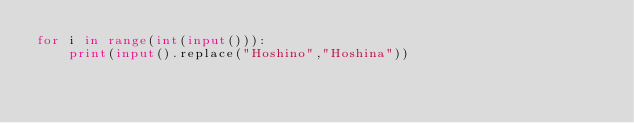Convert code to text. <code><loc_0><loc_0><loc_500><loc_500><_Python_>for i in range(int(input())):
    print(input().replace("Hoshino","Hoshina"))</code> 